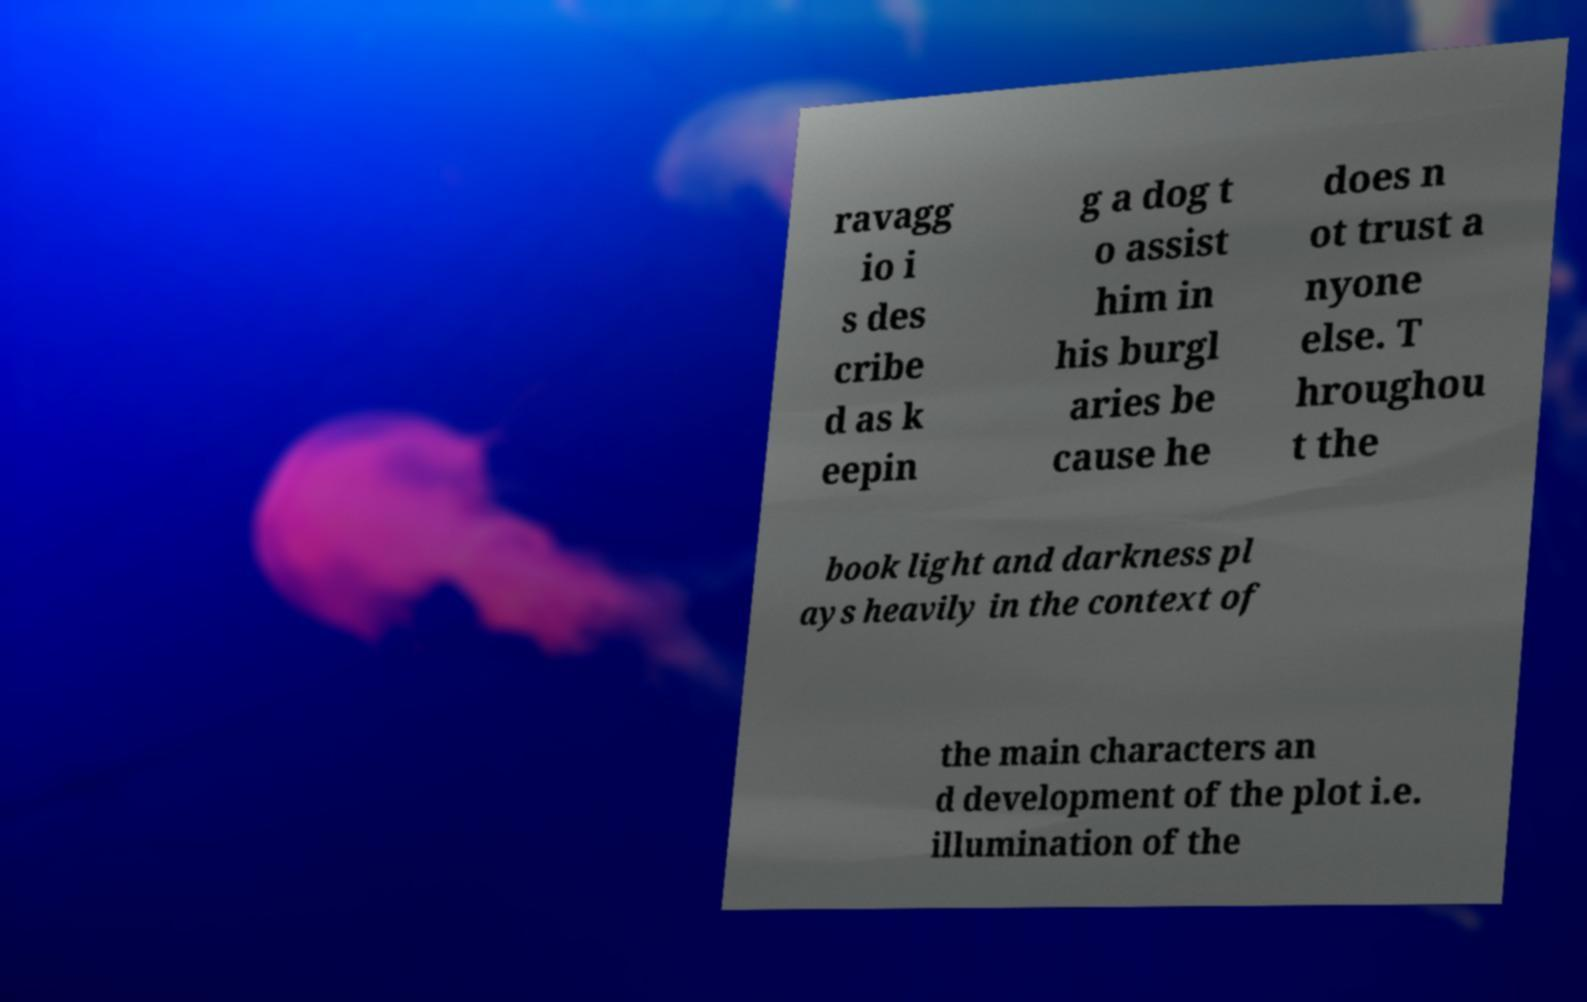Can you read and provide the text displayed in the image?This photo seems to have some interesting text. Can you extract and type it out for me? ravagg io i s des cribe d as k eepin g a dog t o assist him in his burgl aries be cause he does n ot trust a nyone else. T hroughou t the book light and darkness pl ays heavily in the context of the main characters an d development of the plot i.e. illumination of the 